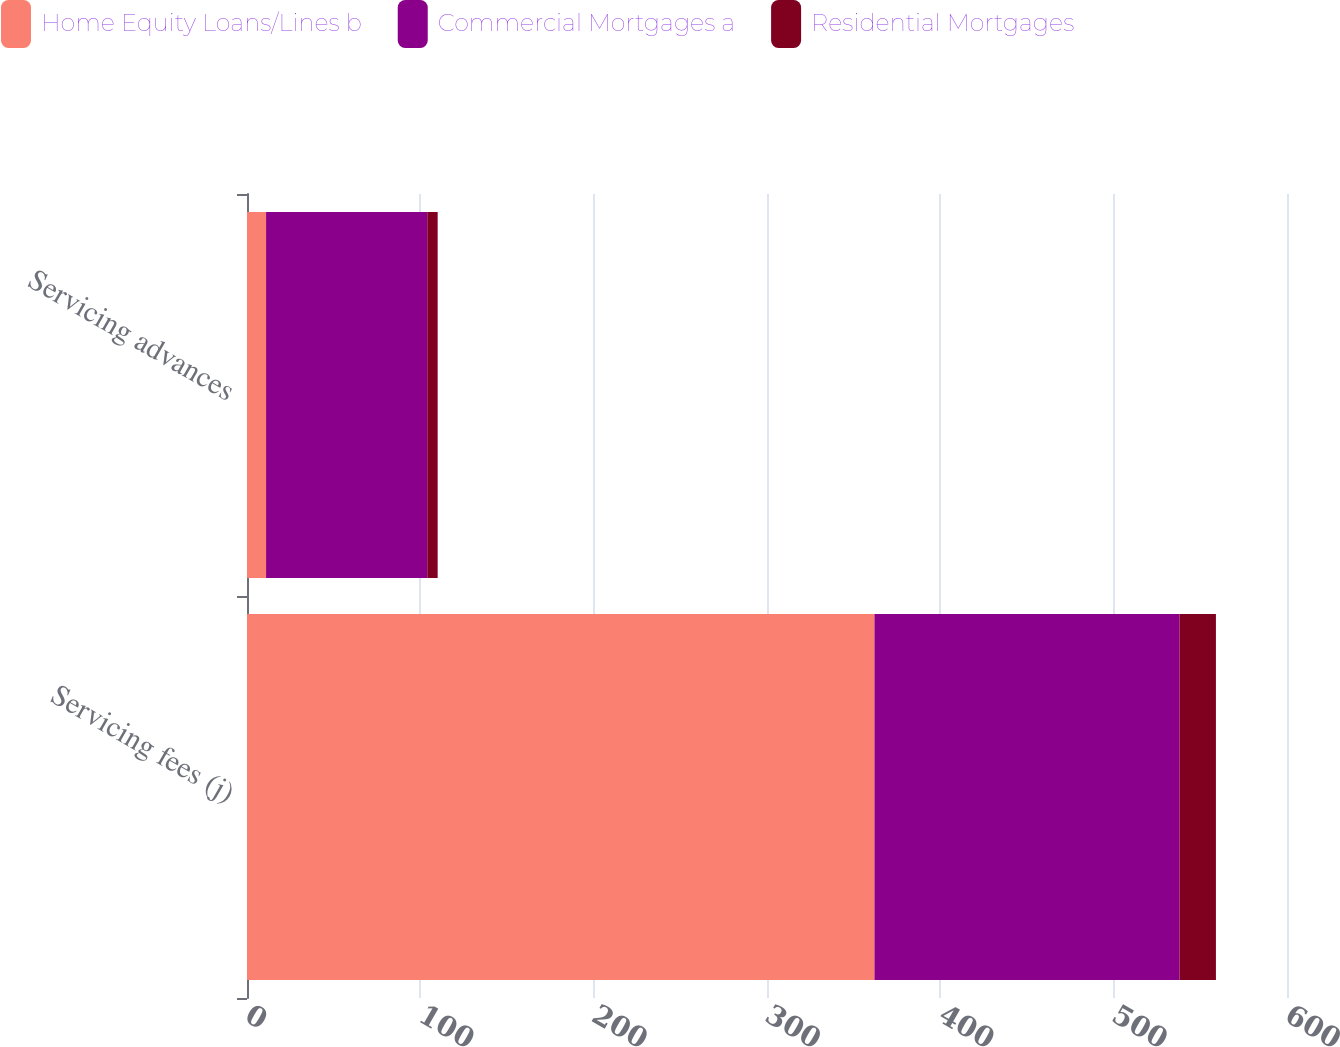<chart> <loc_0><loc_0><loc_500><loc_500><stacked_bar_chart><ecel><fcel>Servicing fees (j)<fcel>Servicing advances<nl><fcel>Home Equity Loans/Lines b<fcel>362<fcel>11<nl><fcel>Commercial Mortgages a<fcel>176<fcel>93<nl><fcel>Residential Mortgages<fcel>21<fcel>6<nl></chart> 